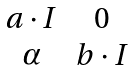Convert formula to latex. <formula><loc_0><loc_0><loc_500><loc_500>\begin{matrix} a \cdot I & 0 \\ \alpha & b \cdot I \end{matrix}</formula> 